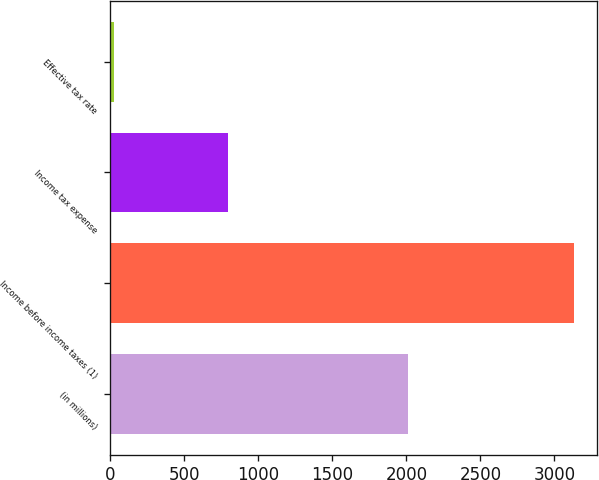Convert chart. <chart><loc_0><loc_0><loc_500><loc_500><bar_chart><fcel>(in millions)<fcel>Income before income taxes (1)<fcel>Income tax expense<fcel>Effective tax rate<nl><fcel>2011<fcel>3133<fcel>796<fcel>25.4<nl></chart> 